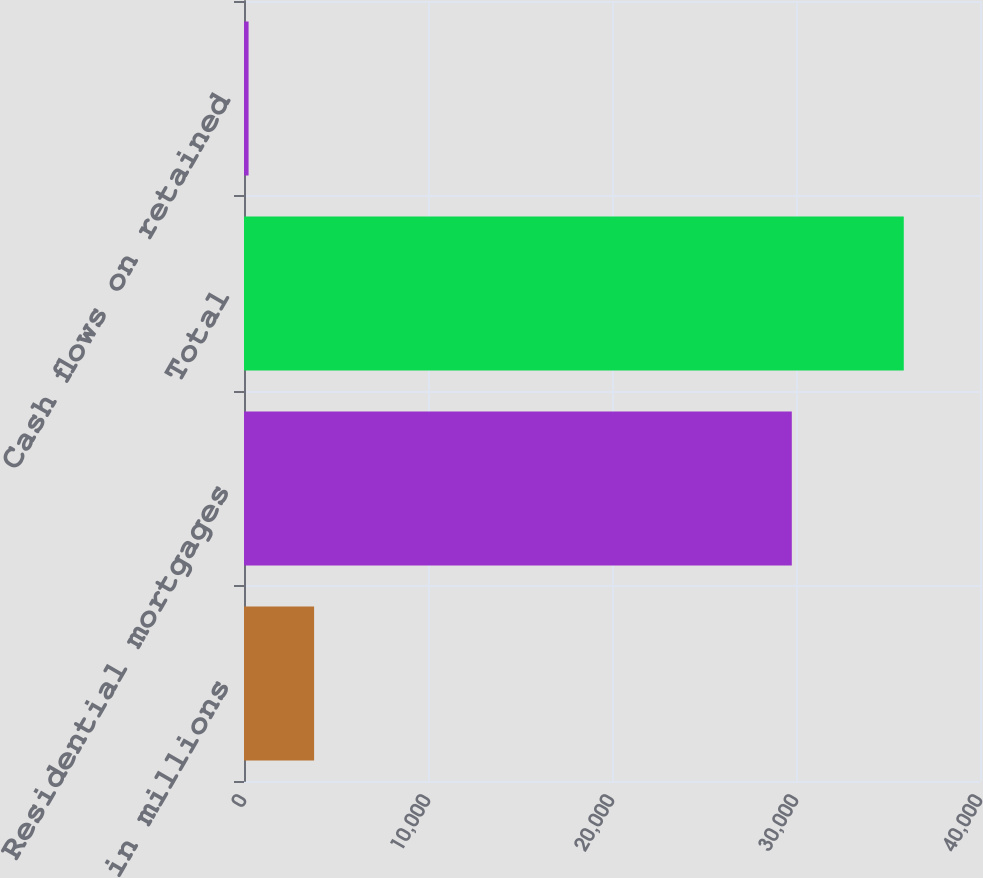Convert chart to OTSL. <chart><loc_0><loc_0><loc_500><loc_500><bar_chart><fcel>in millions<fcel>Residential mortgages<fcel>Total<fcel>Cash flows on retained<nl><fcel>3809.9<fcel>29772<fcel>35858<fcel>249<nl></chart> 